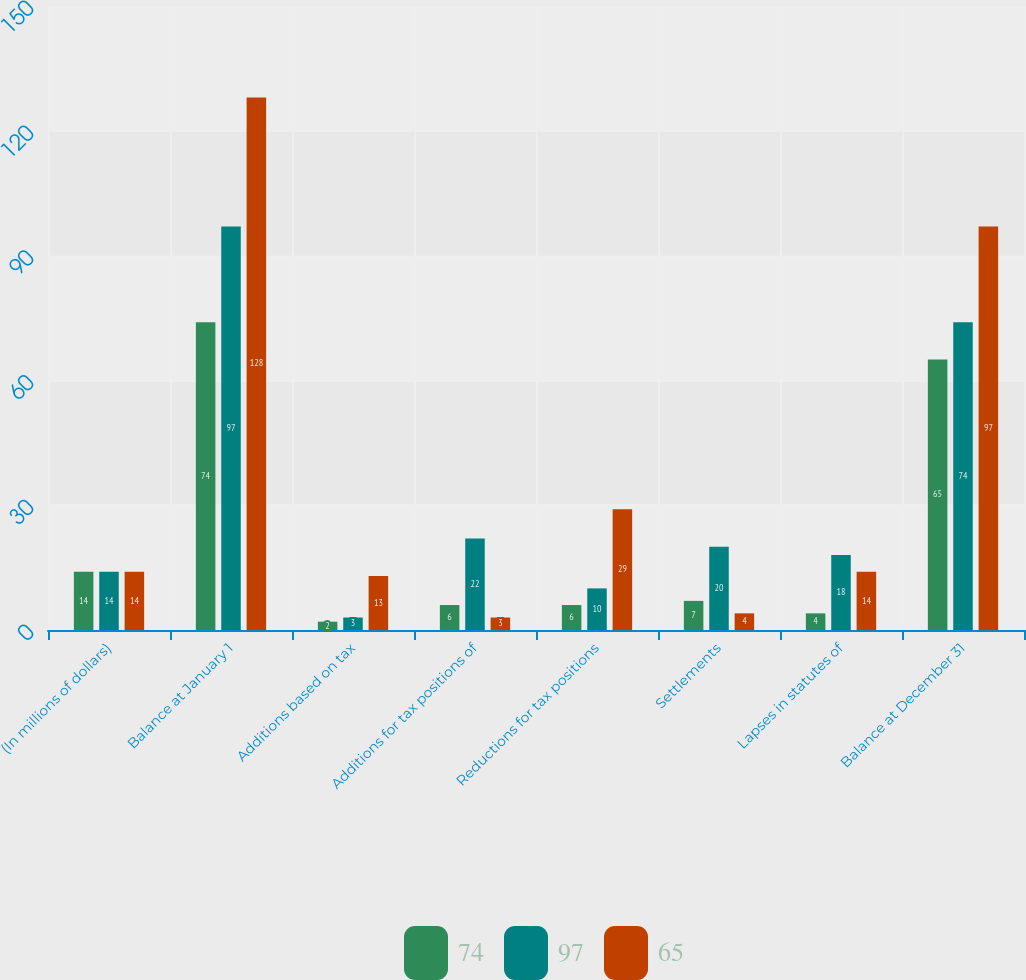<chart> <loc_0><loc_0><loc_500><loc_500><stacked_bar_chart><ecel><fcel>(In millions of dollars)<fcel>Balance at January 1<fcel>Additions based on tax<fcel>Additions for tax positions of<fcel>Reductions for tax positions<fcel>Settlements<fcel>Lapses in statutes of<fcel>Balance at December 31<nl><fcel>74<fcel>14<fcel>74<fcel>2<fcel>6<fcel>6<fcel>7<fcel>4<fcel>65<nl><fcel>97<fcel>14<fcel>97<fcel>3<fcel>22<fcel>10<fcel>20<fcel>18<fcel>74<nl><fcel>65<fcel>14<fcel>128<fcel>13<fcel>3<fcel>29<fcel>4<fcel>14<fcel>97<nl></chart> 